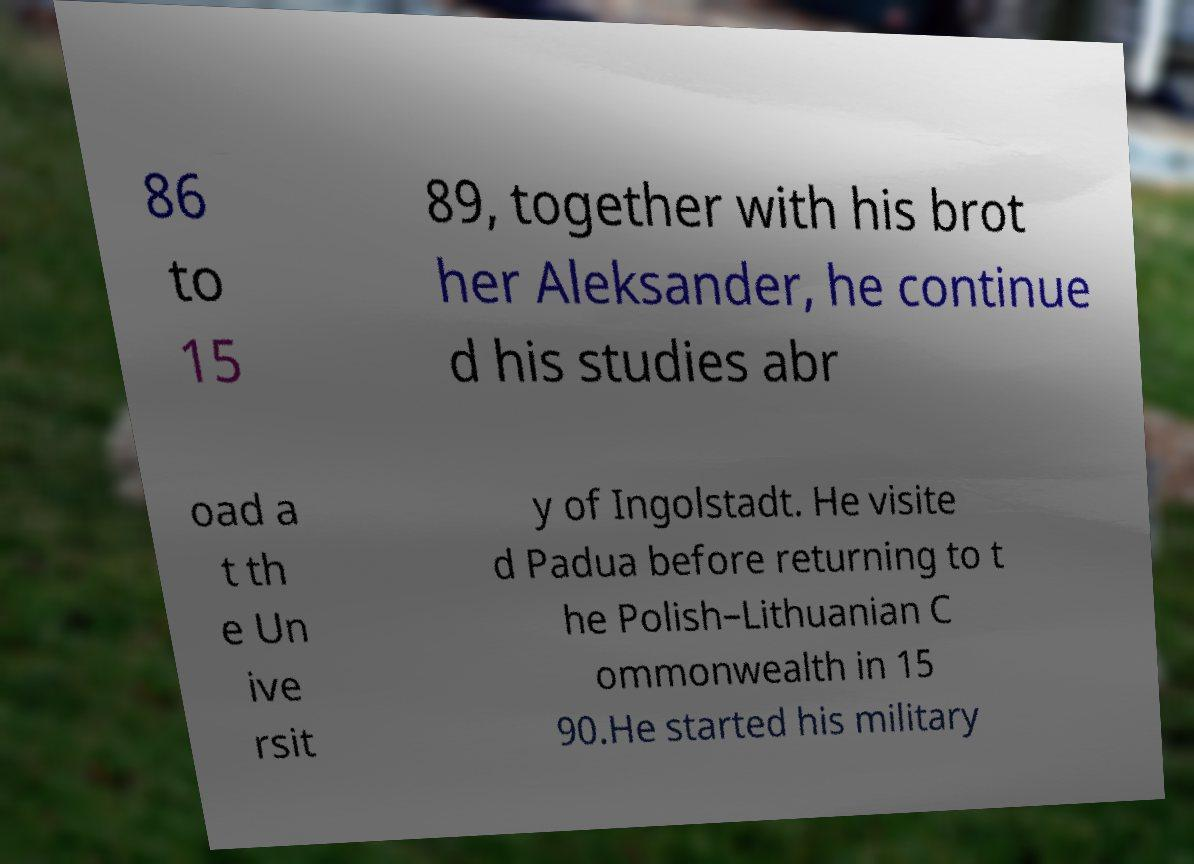For documentation purposes, I need the text within this image transcribed. Could you provide that? 86 to 15 89, together with his brot her Aleksander, he continue d his studies abr oad a t th e Un ive rsit y of Ingolstadt. He visite d Padua before returning to t he Polish–Lithuanian C ommonwealth in 15 90.He started his military 